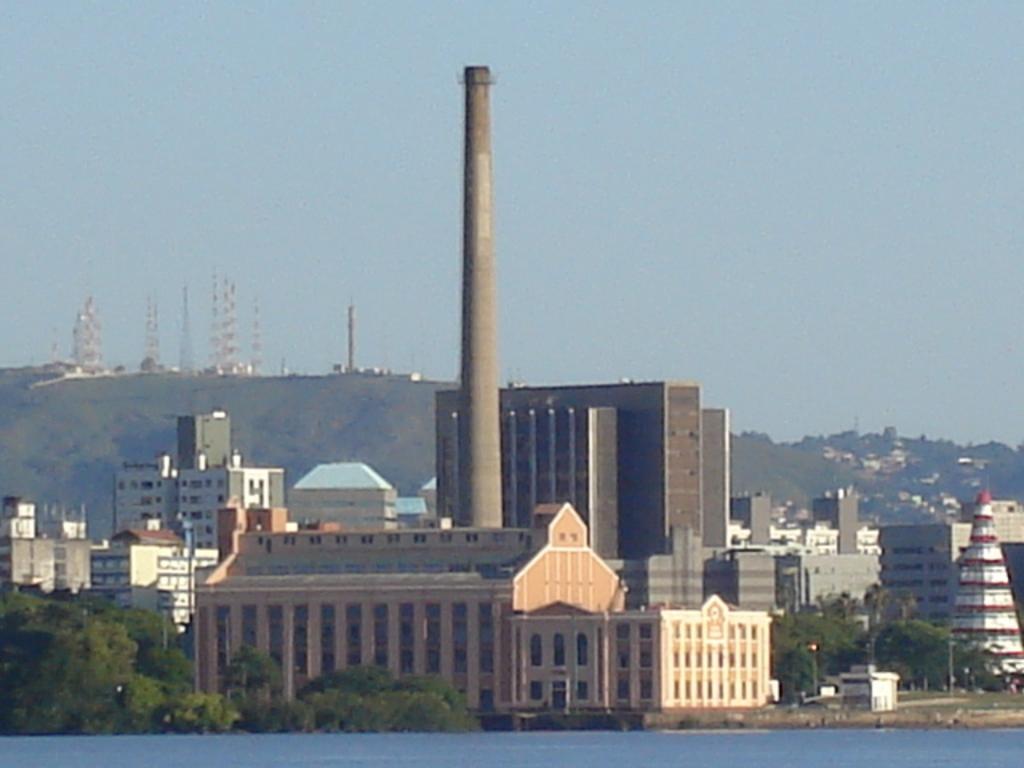Please provide a concise description of this image. Here at the top of the picture we can see the sky and at the bottom of the picture we can see the river. In the middle of the picture we have trees,houses and factories and a chimney. 